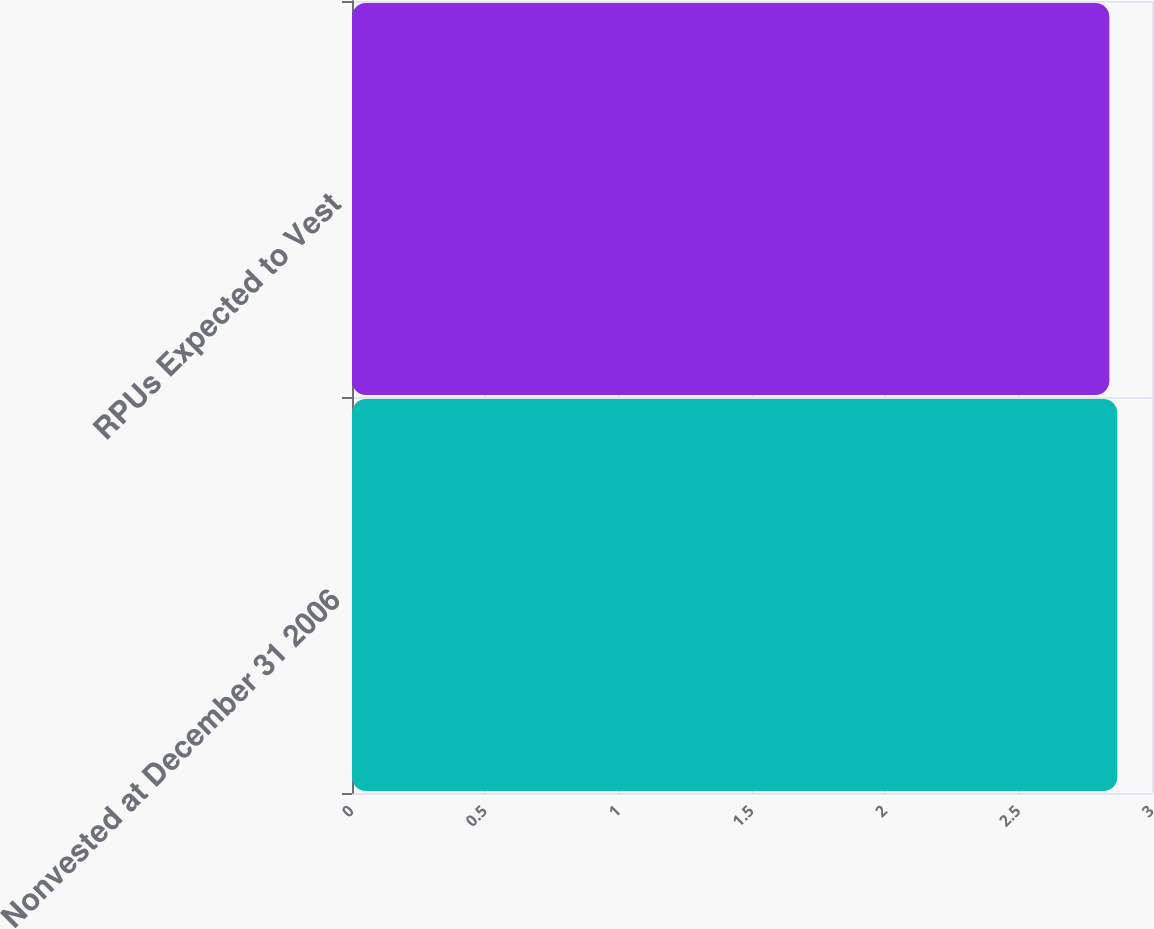<chart> <loc_0><loc_0><loc_500><loc_500><bar_chart><fcel>Nonvested at December 31 2006<fcel>RPUs Expected to Vest<nl><fcel>2.87<fcel>2.84<nl></chart> 